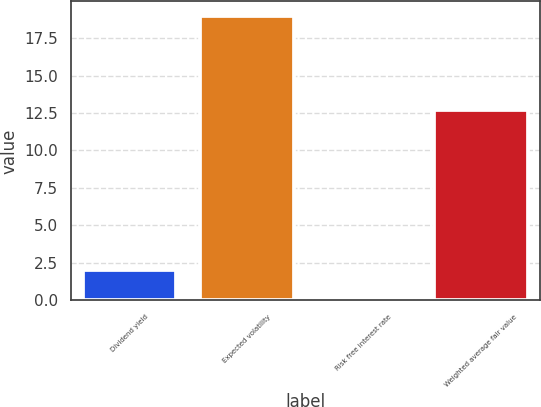Convert chart. <chart><loc_0><loc_0><loc_500><loc_500><bar_chart><fcel>Dividend yield<fcel>Expected volatility<fcel>Risk free interest rate<fcel>Weighted average fair value<nl><fcel>1.99<fcel>19<fcel>0.1<fcel>12.67<nl></chart> 